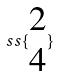<formula> <loc_0><loc_0><loc_500><loc_500>s s \{ \begin{matrix} 2 \\ 4 \end{matrix} \}</formula> 